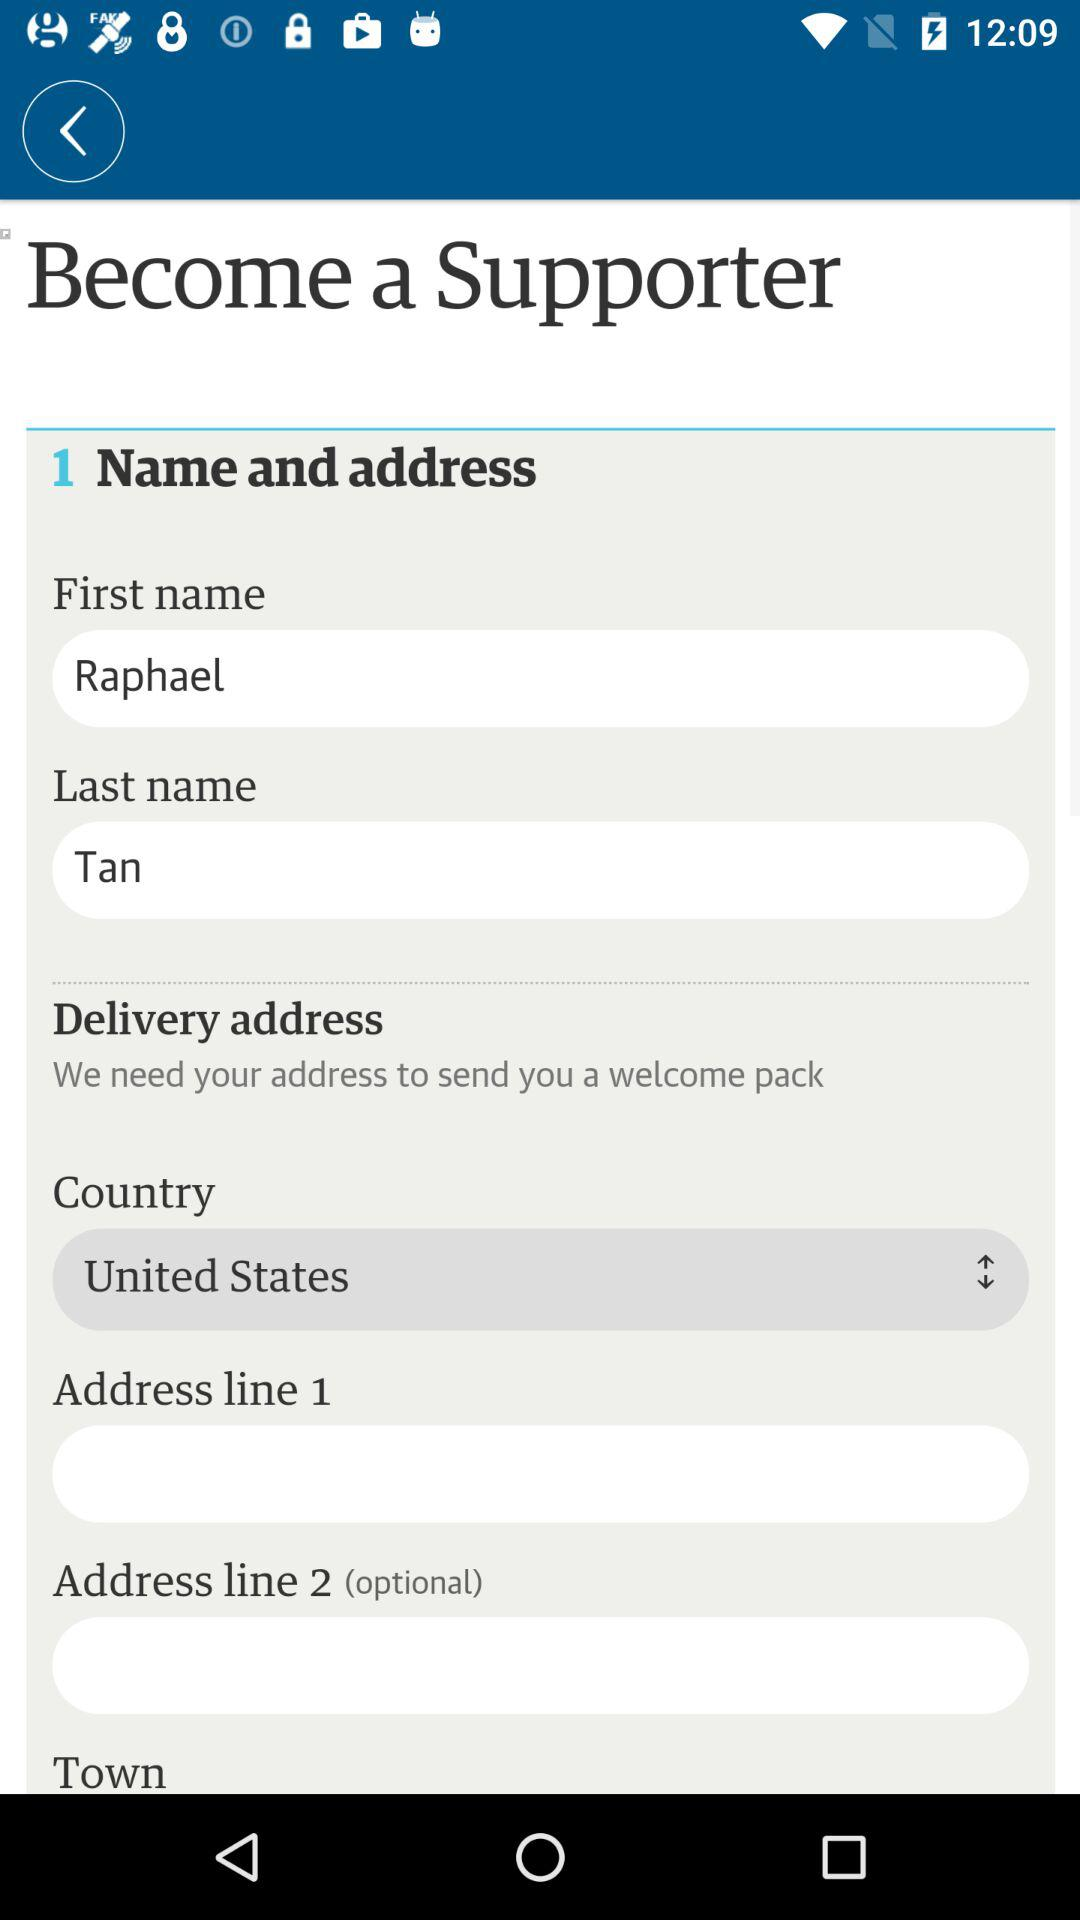What is the first name? The first name is Raphael. 